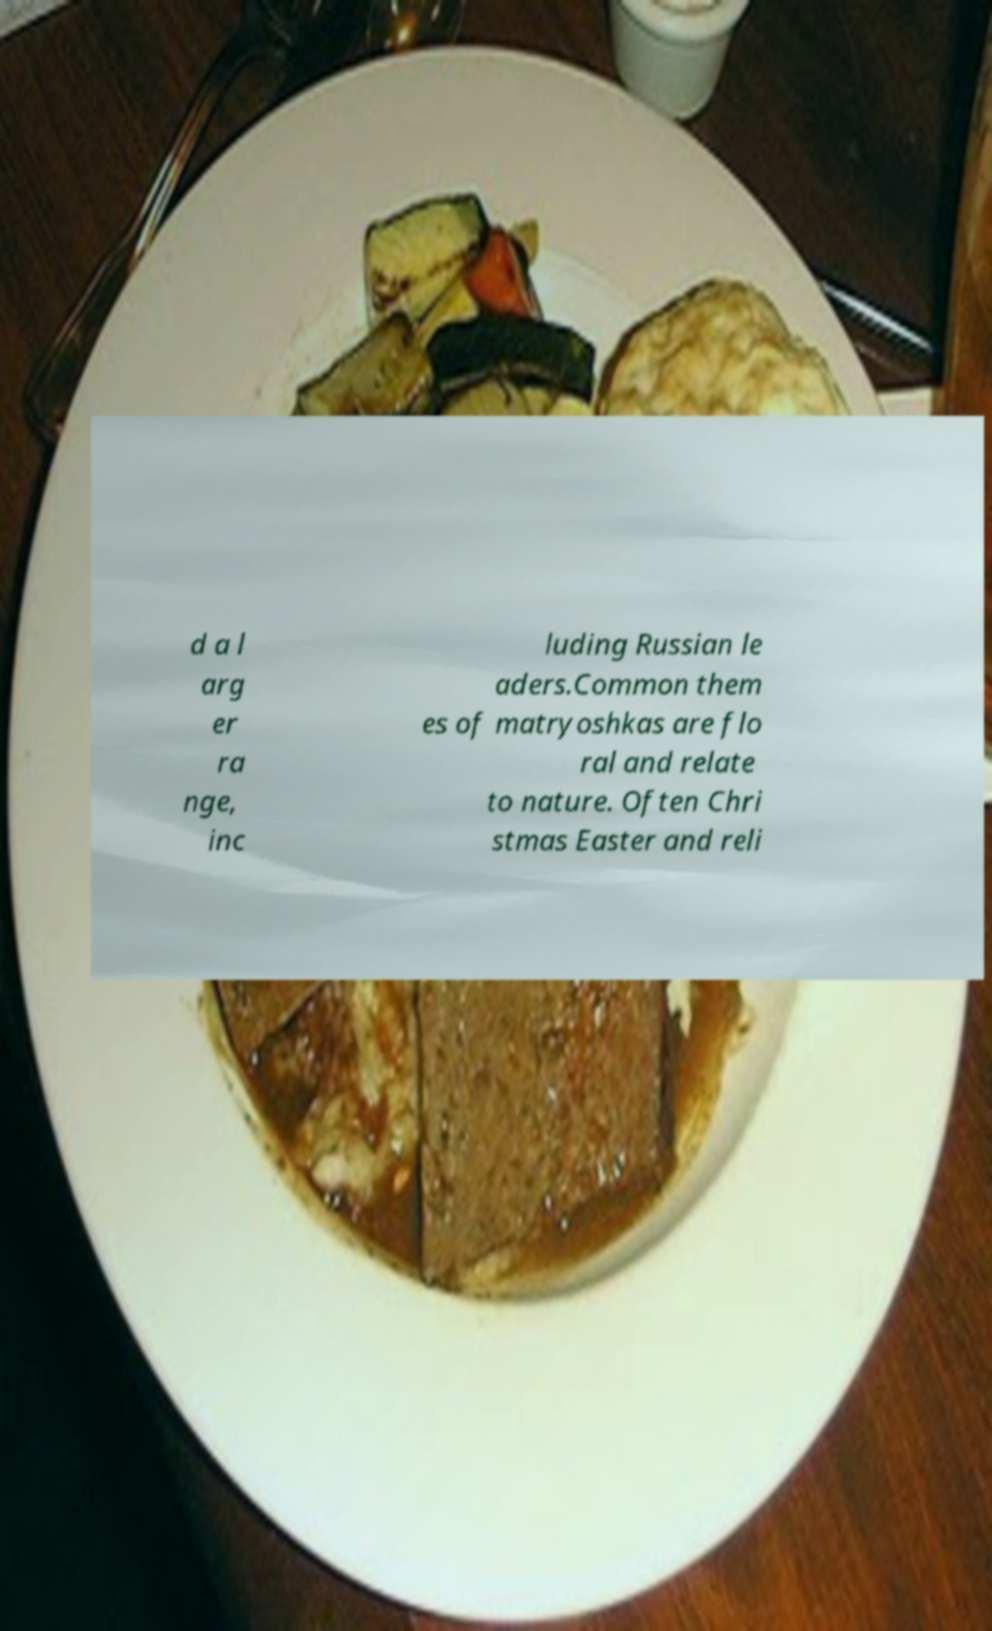Can you read and provide the text displayed in the image?This photo seems to have some interesting text. Can you extract and type it out for me? d a l arg er ra nge, inc luding Russian le aders.Common them es of matryoshkas are flo ral and relate to nature. Often Chri stmas Easter and reli 